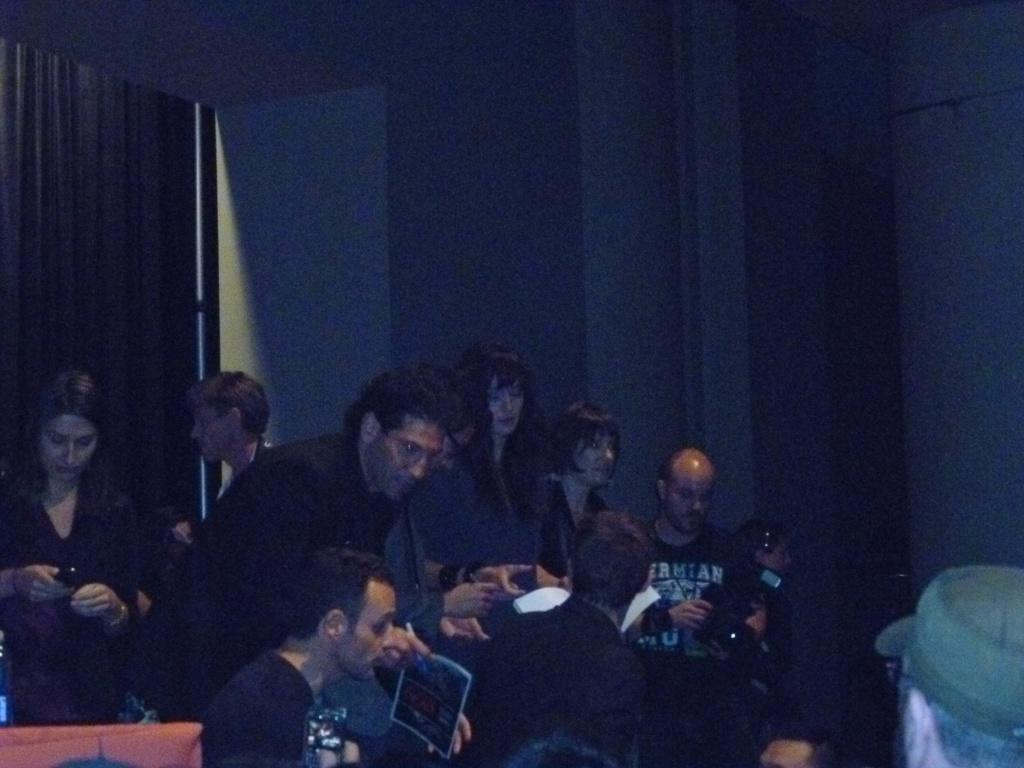What can be seen in the image involving multiple individuals? There is a group of people in the image. What are the people in the image holding? The people are holding objects. Can you describe the objects present in the image? There are objects in the image, but their specific nature is not mentioned in the provided facts. What architectural feature can be seen in the image? There is a door in the image. What color is the silverware being used by the team in the image? There is no mention of silverware or a team in the provided facts, so we cannot answer this question based on the image. 